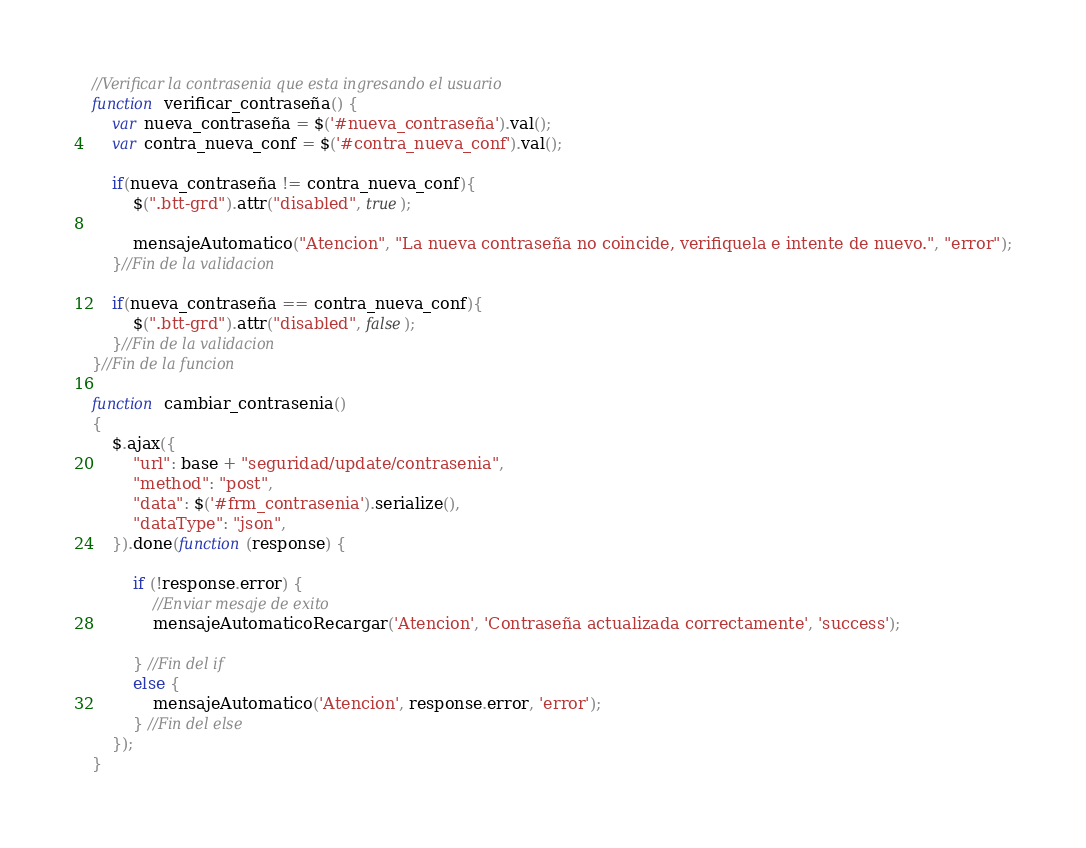<code> <loc_0><loc_0><loc_500><loc_500><_JavaScript_>//Verificar la contrasenia que esta ingresando el usuario
function verificar_contraseña() {
    var nueva_contraseña = $('#nueva_contraseña').val();
    var contra_nueva_conf = $('#contra_nueva_conf').val();

    if(nueva_contraseña != contra_nueva_conf){
        $(".btt-grd").attr("disabled", true);

        mensajeAutomatico("Atencion", "La nueva contraseña no coincide, verifiquela e intente de nuevo.", "error");
    }//Fin de la validacion

    if(nueva_contraseña == contra_nueva_conf){
        $(".btt-grd").attr("disabled", false);
    }//Fin de la validacion
}//Fin de la funcion

function cambiar_contrasenia()
{
    $.ajax({
        "url": base + "seguridad/update/contrasenia",
        "method": "post",
        "data": $('#frm_contrasenia').serialize(),
        "dataType": "json",
    }).done(function(response) {
        
        if (!response.error) {
            //Enviar mesaje de exito
            mensajeAutomaticoRecargar('Atencion', 'Contraseña actualizada correctamente', 'success');
            
        } //Fin del if
        else {
            mensajeAutomatico('Atencion', response.error, 'error');
        } //Fin del else
    });
}</code> 